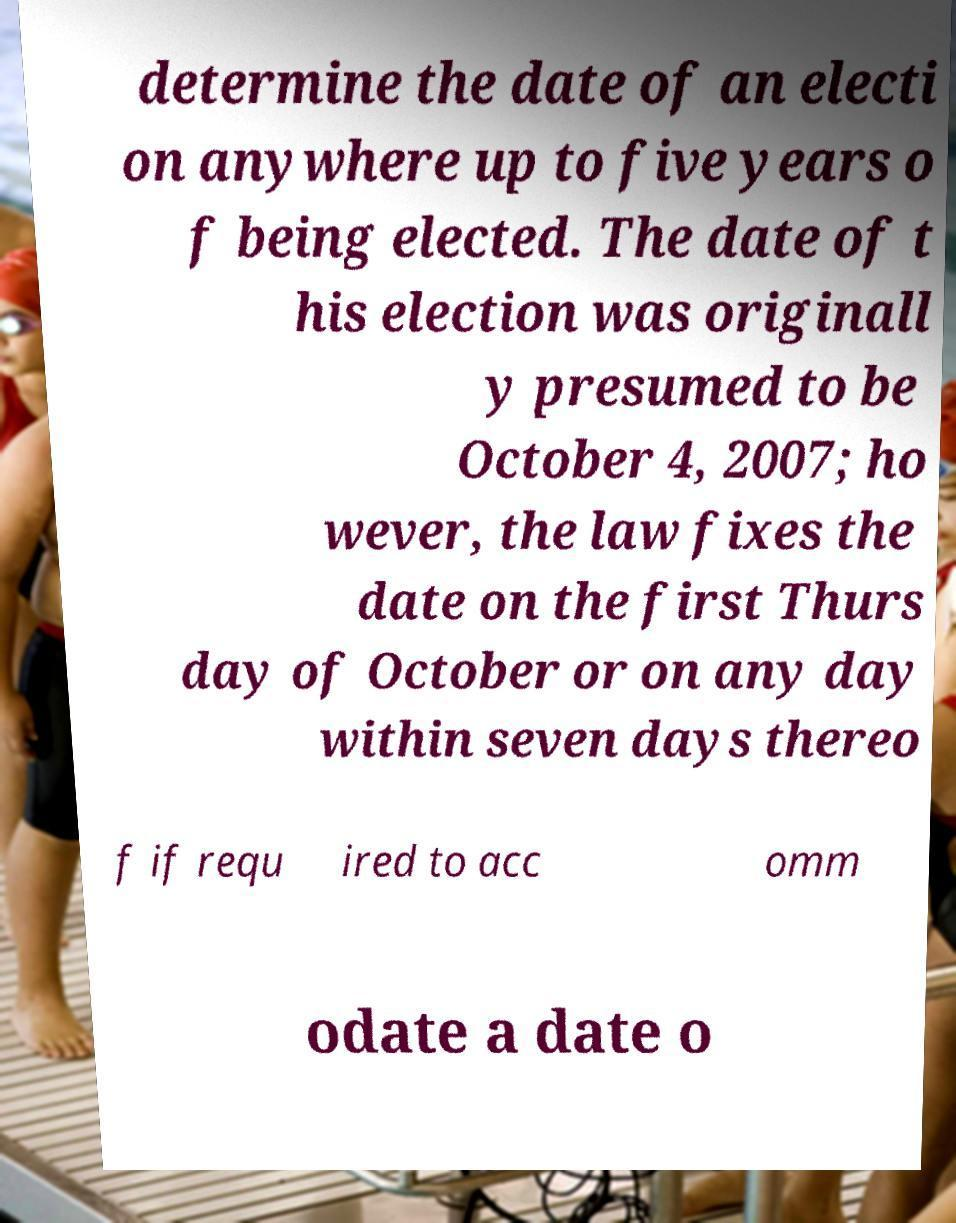For documentation purposes, I need the text within this image transcribed. Could you provide that? determine the date of an electi on anywhere up to five years o f being elected. The date of t his election was originall y presumed to be October 4, 2007; ho wever, the law fixes the date on the first Thurs day of October or on any day within seven days thereo f if requ ired to acc omm odate a date o 